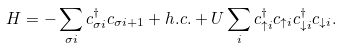<formula> <loc_0><loc_0><loc_500><loc_500>H = - \sum _ { \sigma i } c ^ { \dagger } _ { \sigma i } c _ { \sigma i + 1 } + h . c . + U \sum _ { i } c ^ { \dagger } _ { \uparrow i } c _ { \uparrow i } c ^ { \dagger } _ { \downarrow i } c _ { \downarrow i } .</formula> 